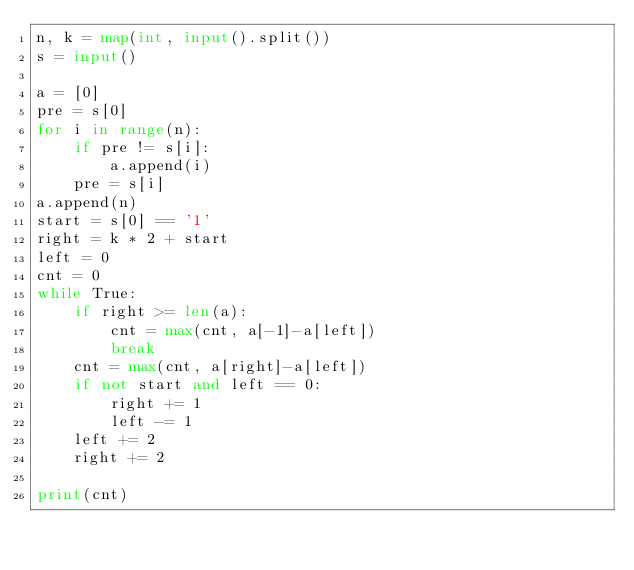<code> <loc_0><loc_0><loc_500><loc_500><_Python_>n, k = map(int, input().split())
s = input()

a = [0]
pre = s[0]
for i in range(n):
    if pre != s[i]:
        a.append(i)
    pre = s[i]
a.append(n)
start = s[0] == '1'
right = k * 2 + start
left = 0
cnt = 0
while True:
    if right >= len(a):
        cnt = max(cnt, a[-1]-a[left])
        break
    cnt = max(cnt, a[right]-a[left])
    if not start and left == 0:
        right += 1
        left -= 1
    left += 2
    right += 2

print(cnt)</code> 